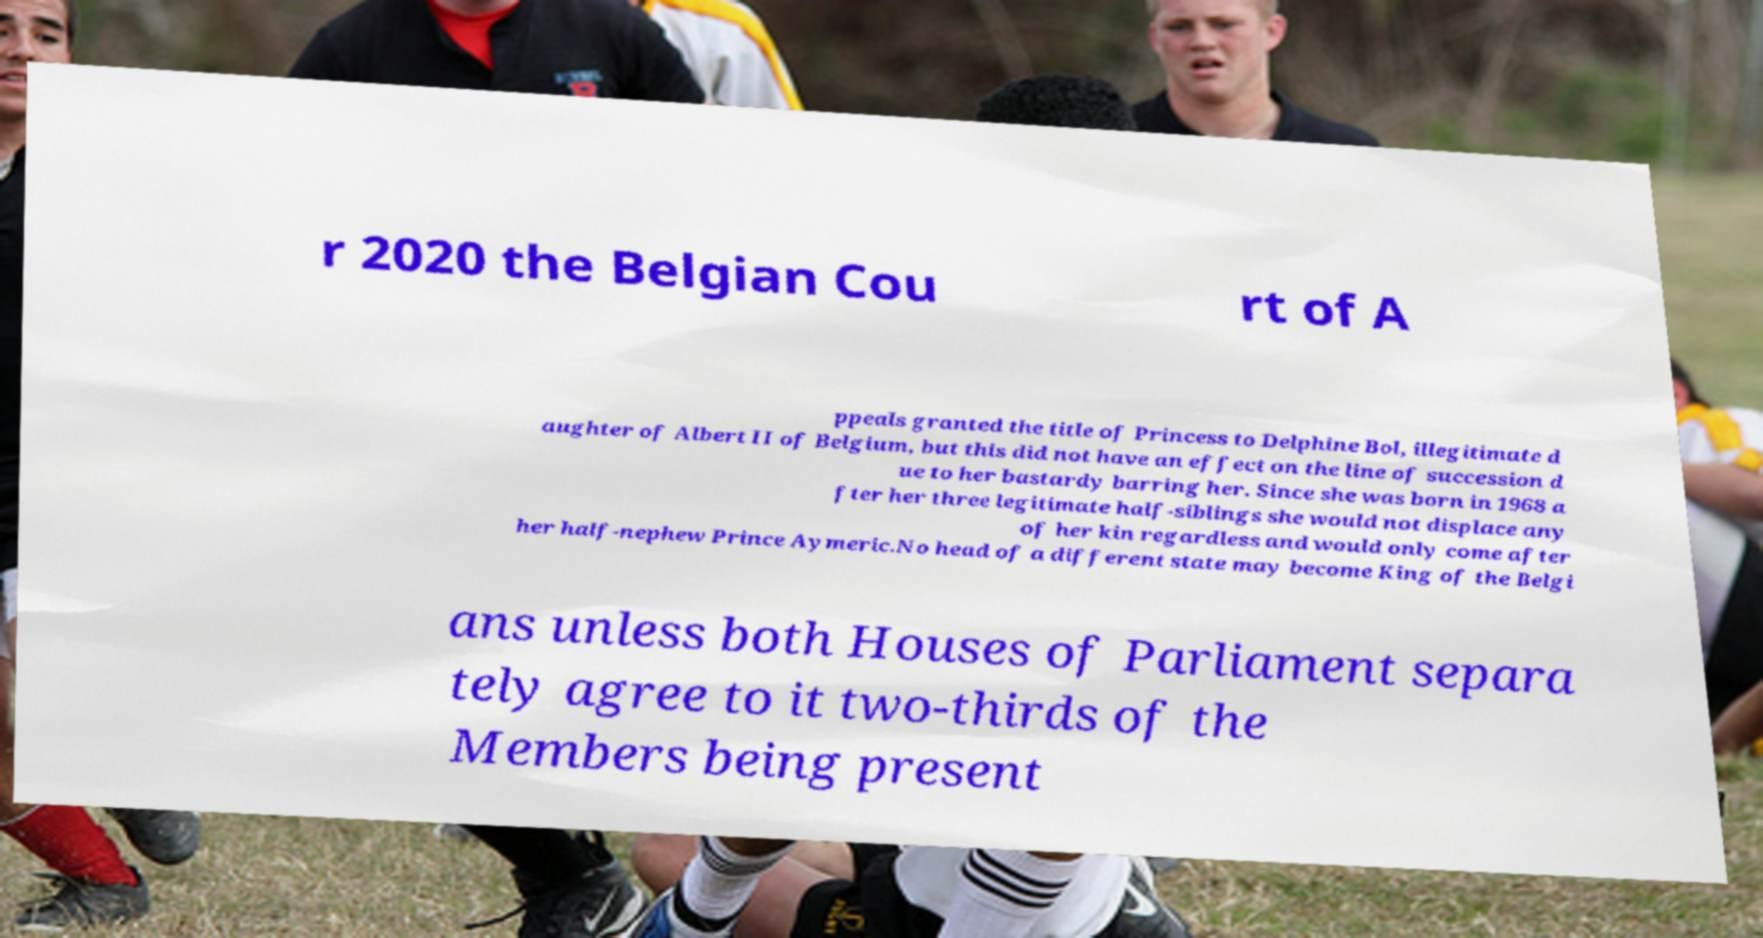Can you read and provide the text displayed in the image?This photo seems to have some interesting text. Can you extract and type it out for me? r 2020 the Belgian Cou rt of A ppeals granted the title of Princess to Delphine Bol, illegitimate d aughter of Albert II of Belgium, but this did not have an effect on the line of succession d ue to her bastardy barring her. Since she was born in 1968 a fter her three legitimate half-siblings she would not displace any of her kin regardless and would only come after her half-nephew Prince Aymeric.No head of a different state may become King of the Belgi ans unless both Houses of Parliament separa tely agree to it two-thirds of the Members being present 